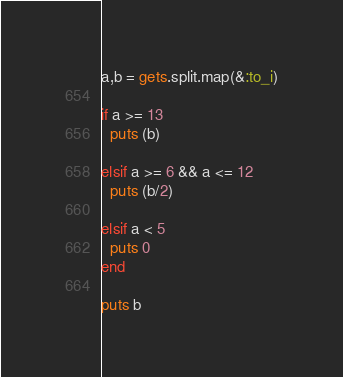Convert code to text. <code><loc_0><loc_0><loc_500><loc_500><_Ruby_>
a,b = gets.split.map(&:to_i)

if a >= 13
  puts (b)

elsif a >= 6 && a <= 12
  puts (b/2)

elsif a < 5
  puts 0
end

puts b</code> 